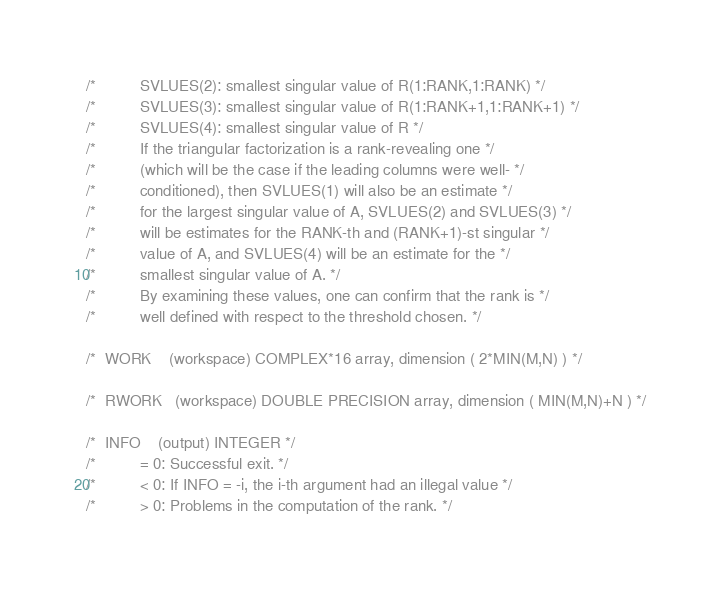Convert code to text. <code><loc_0><loc_0><loc_500><loc_500><_C_>/*          SVLUES(2): smallest singular value of R(1:RANK,1:RANK) */
/*          SVLUES(3): smallest singular value of R(1:RANK+1,1:RANK+1) */
/*          SVLUES(4): smallest singular value of R */
/*          If the triangular factorization is a rank-revealing one */
/*          (which will be the case if the leading columns were well- */
/*          conditioned), then SVLUES(1) will also be an estimate */
/*          for the largest singular value of A, SVLUES(2) and SVLUES(3) */
/*          will be estimates for the RANK-th and (RANK+1)-st singular */
/*          value of A, and SVLUES(4) will be an estimate for the */
/*          smallest singular value of A. */
/*          By examining these values, one can confirm that the rank is */
/*          well defined with respect to the threshold chosen. */

/*  WORK    (workspace) COMPLEX*16 array, dimension ( 2*MIN(M,N) ) */

/*  RWORK   (workspace) DOUBLE PRECISION array, dimension ( MIN(M,N)+N ) */

/*  INFO    (output) INTEGER */
/*          = 0: Successful exit. */
/*          < 0: If INFO = -i, the i-th argument had an illegal value */
/*          > 0: Problems in the computation of the rank. */</code> 